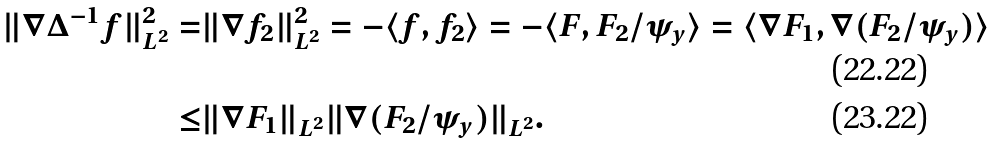<formula> <loc_0><loc_0><loc_500><loc_500>\| \nabla \Delta ^ { - 1 } f \| _ { L ^ { 2 } } ^ { 2 } = & \| \nabla f _ { 2 } \| _ { L ^ { 2 } } ^ { 2 } = - \langle f , f _ { 2 } \rangle = - \langle F , F _ { 2 } / \psi _ { y } \rangle = \langle \nabla F _ { 1 } , \nabla ( F _ { 2 } / \psi _ { y } ) \rangle \\ \leq & \| \nabla F _ { 1 } \| _ { L ^ { 2 } } \| \nabla ( F _ { 2 } / \psi _ { y } ) \| _ { L ^ { 2 } } .</formula> 